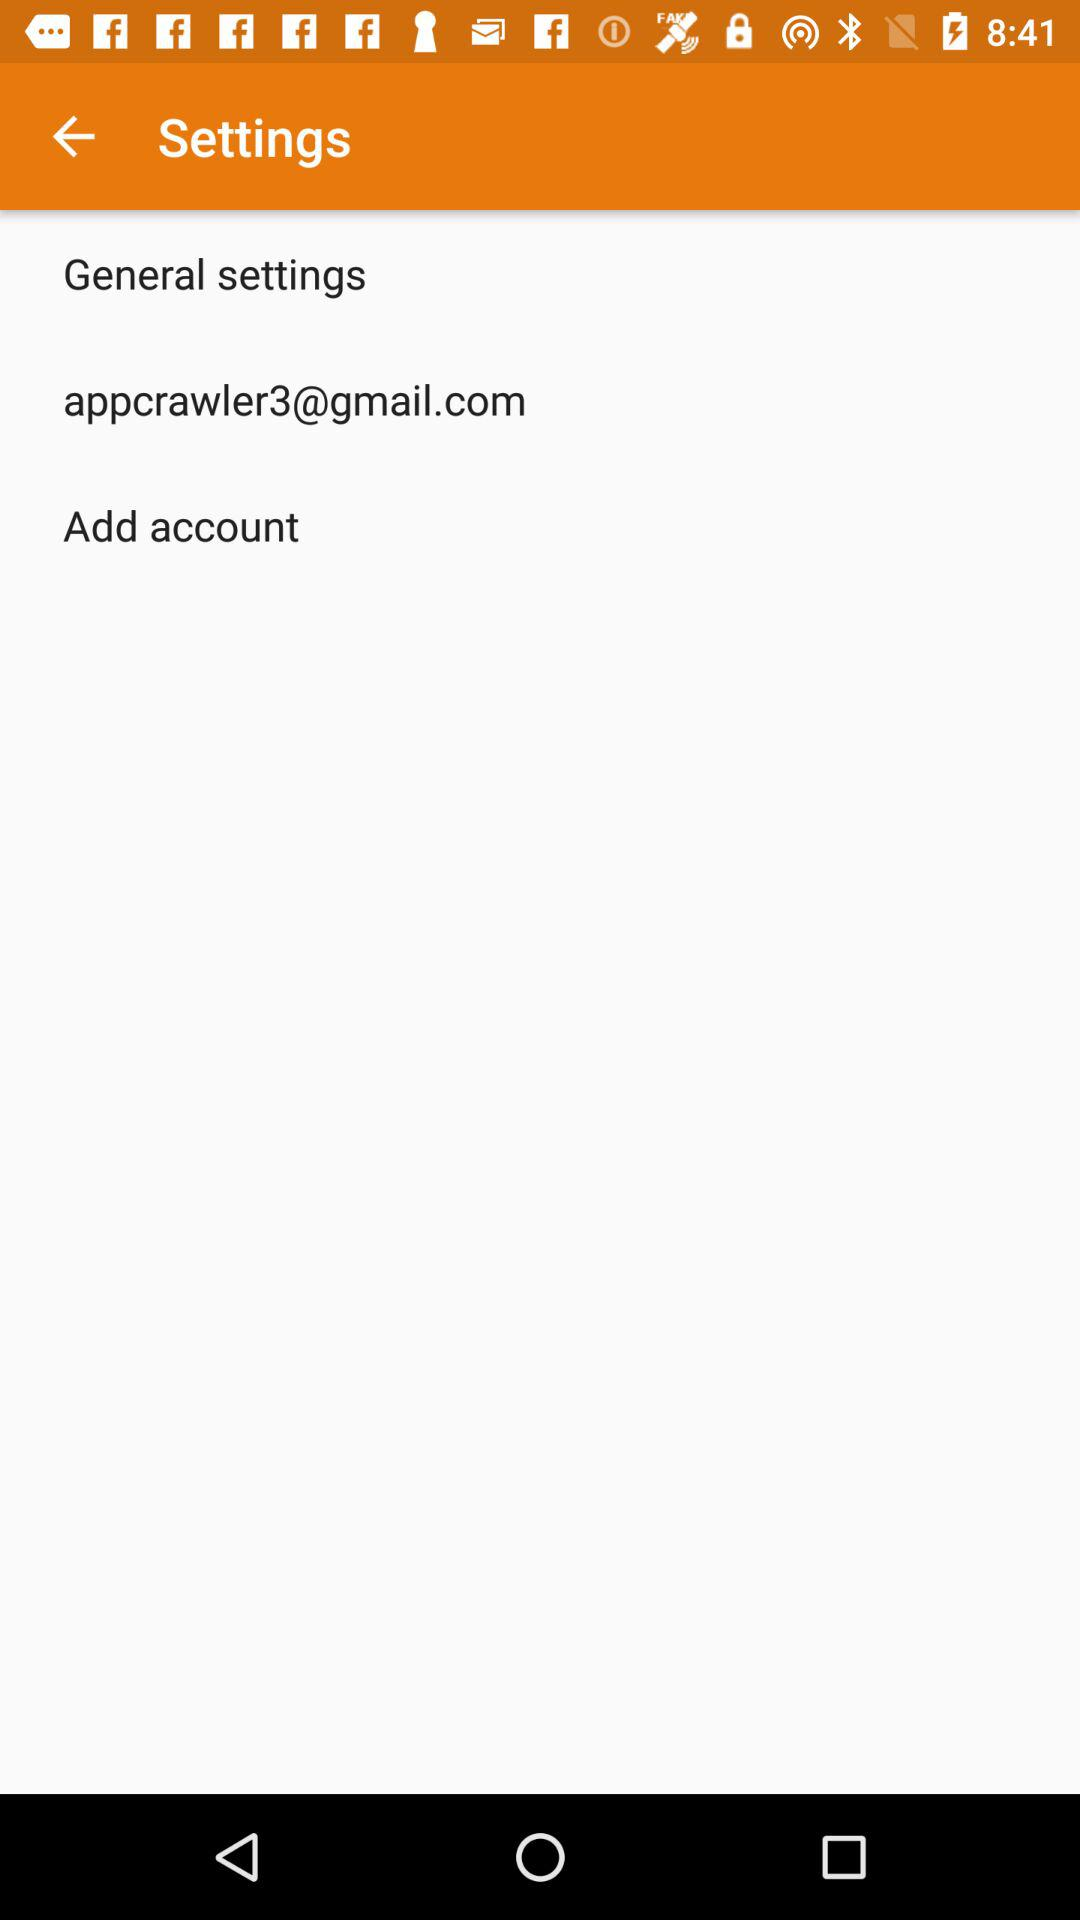What is the email address? The email address is appcrawler3@gmail.com. 